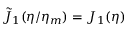<formula> <loc_0><loc_0><loc_500><loc_500>\tilde { J } _ { 1 } ( \eta / \eta _ { m } ) = J _ { 1 } ( \eta )</formula> 